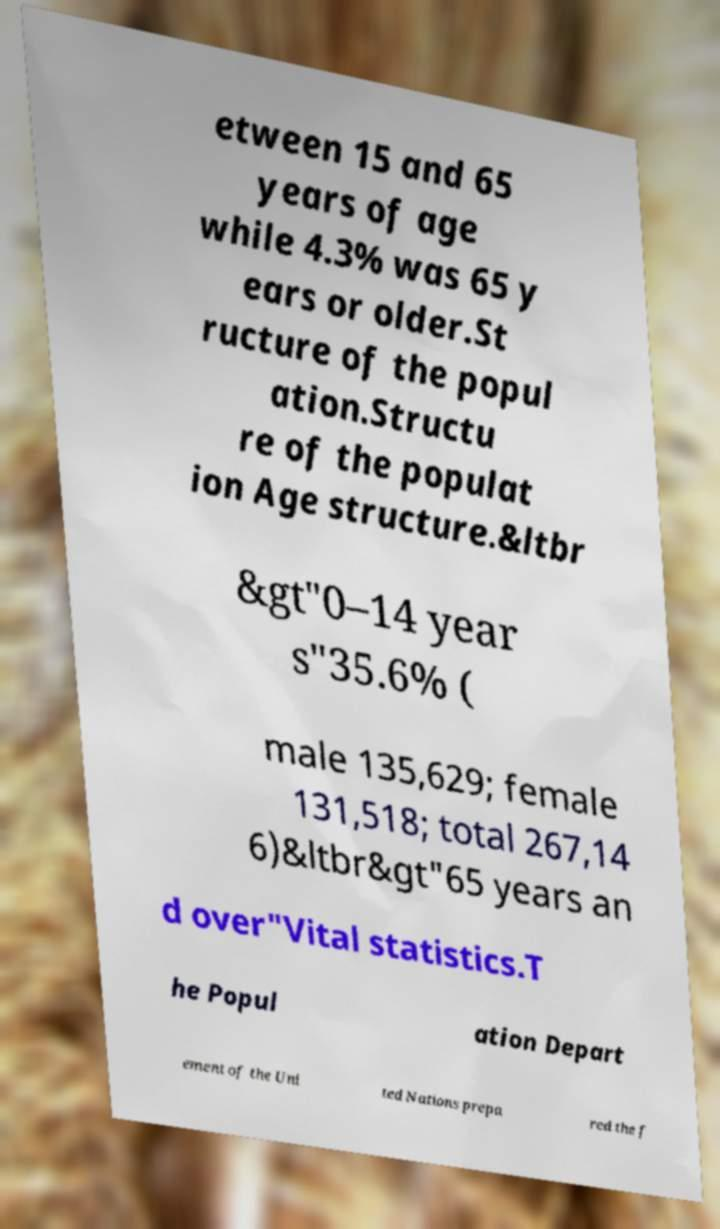Could you extract and type out the text from this image? etween 15 and 65 years of age while 4.3% was 65 y ears or older.St ructure of the popul ation.Structu re of the populat ion Age structure.&ltbr &gt"0–14 year s"35.6% ( male 135,629; female 131,518; total 267,14 6)&ltbr&gt"65 years an d over"Vital statistics.T he Popul ation Depart ement of the Uni ted Nations prepa red the f 